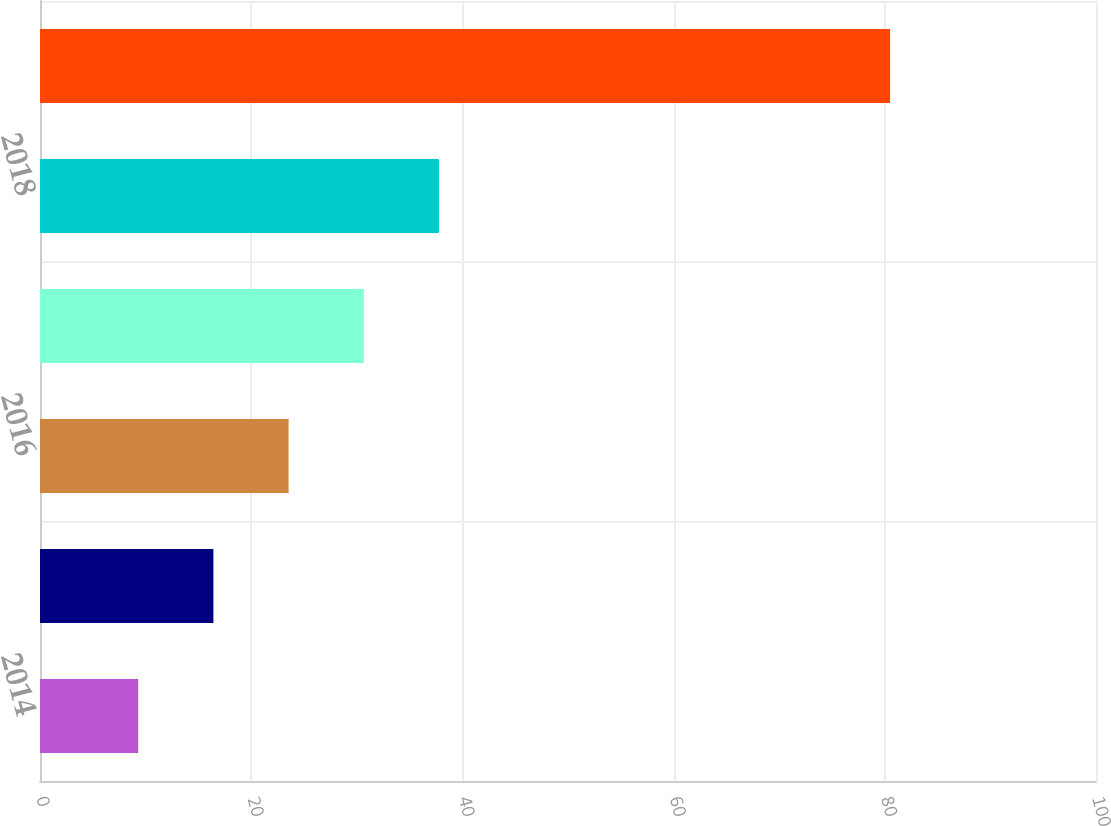Convert chart to OTSL. <chart><loc_0><loc_0><loc_500><loc_500><bar_chart><fcel>2014<fcel>2015<fcel>2016<fcel>2017<fcel>2018<fcel>2019-2023<nl><fcel>9.3<fcel>16.42<fcel>23.54<fcel>30.66<fcel>37.78<fcel>80.5<nl></chart> 